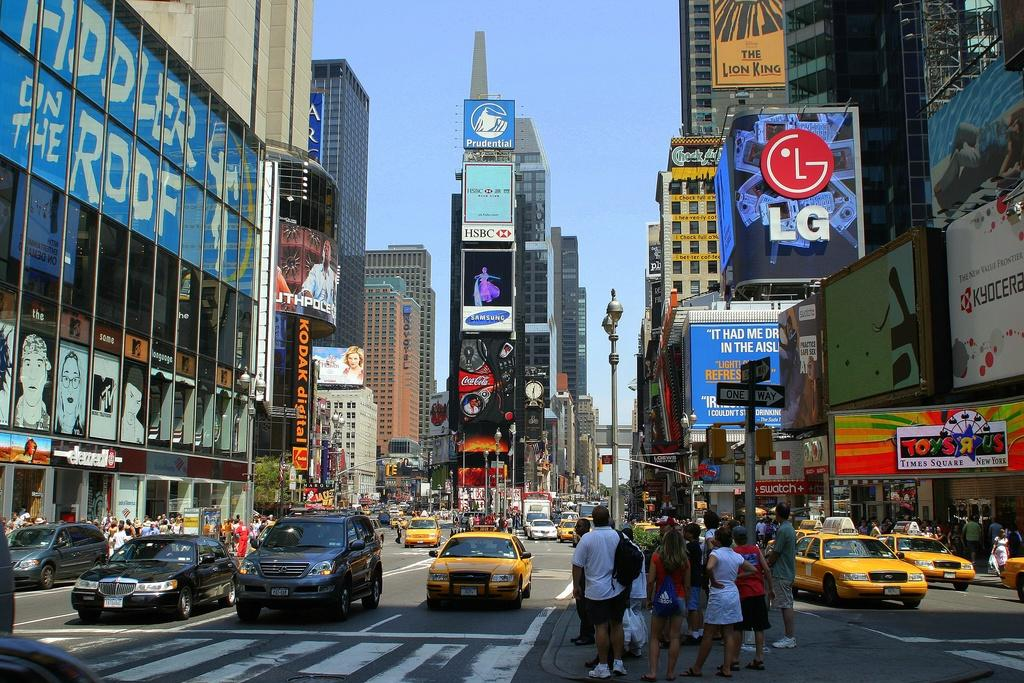<image>
Summarize the visual content of the image. a sign above the street that says LG 